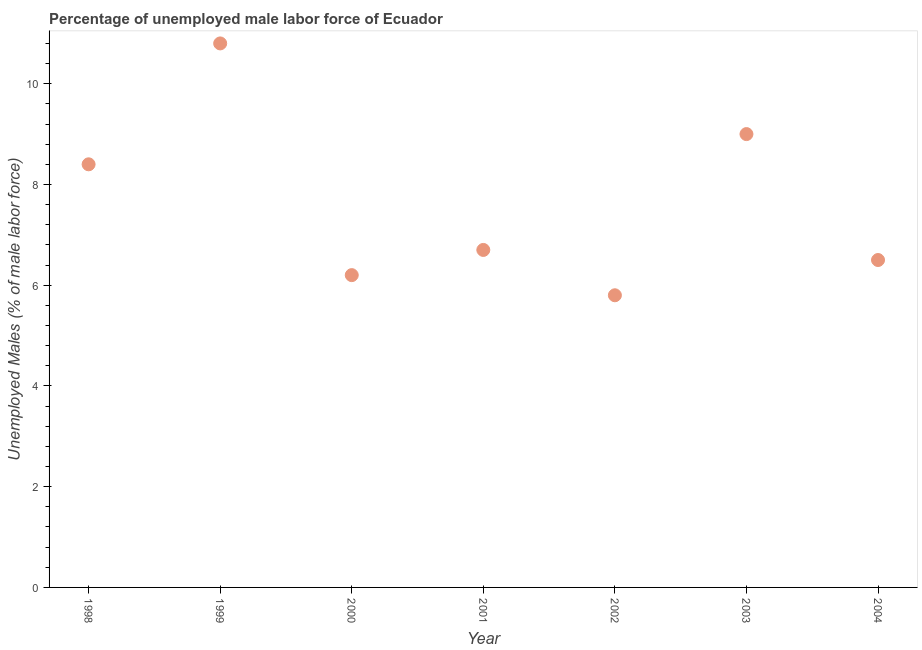What is the total unemployed male labour force in 2000?
Make the answer very short. 6.2. Across all years, what is the maximum total unemployed male labour force?
Your answer should be compact. 10.8. Across all years, what is the minimum total unemployed male labour force?
Give a very brief answer. 5.8. In which year was the total unemployed male labour force minimum?
Your answer should be compact. 2002. What is the sum of the total unemployed male labour force?
Your answer should be very brief. 53.4. What is the difference between the total unemployed male labour force in 2001 and 2002?
Give a very brief answer. 0.9. What is the average total unemployed male labour force per year?
Keep it short and to the point. 7.63. What is the median total unemployed male labour force?
Offer a terse response. 6.7. In how many years, is the total unemployed male labour force greater than 6 %?
Keep it short and to the point. 6. What is the ratio of the total unemployed male labour force in 2001 to that in 2004?
Offer a very short reply. 1.03. Is the total unemployed male labour force in 1999 less than that in 2002?
Your response must be concise. No. Is the difference between the total unemployed male labour force in 1998 and 2004 greater than the difference between any two years?
Make the answer very short. No. What is the difference between the highest and the second highest total unemployed male labour force?
Offer a very short reply. 1.8. Is the sum of the total unemployed male labour force in 1999 and 2000 greater than the maximum total unemployed male labour force across all years?
Offer a very short reply. Yes. What is the difference between the highest and the lowest total unemployed male labour force?
Provide a succinct answer. 5. How many dotlines are there?
Your answer should be compact. 1. How many years are there in the graph?
Give a very brief answer. 7. What is the difference between two consecutive major ticks on the Y-axis?
Make the answer very short. 2. Are the values on the major ticks of Y-axis written in scientific E-notation?
Offer a terse response. No. Does the graph contain any zero values?
Offer a very short reply. No. What is the title of the graph?
Your response must be concise. Percentage of unemployed male labor force of Ecuador. What is the label or title of the Y-axis?
Your answer should be compact. Unemployed Males (% of male labor force). What is the Unemployed Males (% of male labor force) in 1998?
Provide a short and direct response. 8.4. What is the Unemployed Males (% of male labor force) in 1999?
Make the answer very short. 10.8. What is the Unemployed Males (% of male labor force) in 2000?
Keep it short and to the point. 6.2. What is the Unemployed Males (% of male labor force) in 2001?
Give a very brief answer. 6.7. What is the Unemployed Males (% of male labor force) in 2002?
Provide a short and direct response. 5.8. What is the Unemployed Males (% of male labor force) in 2003?
Offer a terse response. 9. What is the Unemployed Males (% of male labor force) in 2004?
Your answer should be very brief. 6.5. What is the difference between the Unemployed Males (% of male labor force) in 1998 and 1999?
Make the answer very short. -2.4. What is the difference between the Unemployed Males (% of male labor force) in 1998 and 2000?
Make the answer very short. 2.2. What is the difference between the Unemployed Males (% of male labor force) in 1998 and 2003?
Keep it short and to the point. -0.6. What is the difference between the Unemployed Males (% of male labor force) in 1998 and 2004?
Offer a very short reply. 1.9. What is the difference between the Unemployed Males (% of male labor force) in 1999 and 2001?
Give a very brief answer. 4.1. What is the difference between the Unemployed Males (% of male labor force) in 1999 and 2003?
Your response must be concise. 1.8. What is the difference between the Unemployed Males (% of male labor force) in 1999 and 2004?
Make the answer very short. 4.3. What is the difference between the Unemployed Males (% of male labor force) in 2000 and 2001?
Your answer should be very brief. -0.5. What is the difference between the Unemployed Males (% of male labor force) in 2000 and 2003?
Ensure brevity in your answer.  -2.8. What is the difference between the Unemployed Males (% of male labor force) in 2001 and 2003?
Offer a terse response. -2.3. What is the difference between the Unemployed Males (% of male labor force) in 2002 and 2003?
Give a very brief answer. -3.2. What is the difference between the Unemployed Males (% of male labor force) in 2002 and 2004?
Provide a succinct answer. -0.7. What is the difference between the Unemployed Males (% of male labor force) in 2003 and 2004?
Provide a short and direct response. 2.5. What is the ratio of the Unemployed Males (% of male labor force) in 1998 to that in 1999?
Provide a short and direct response. 0.78. What is the ratio of the Unemployed Males (% of male labor force) in 1998 to that in 2000?
Provide a succinct answer. 1.35. What is the ratio of the Unemployed Males (% of male labor force) in 1998 to that in 2001?
Ensure brevity in your answer.  1.25. What is the ratio of the Unemployed Males (% of male labor force) in 1998 to that in 2002?
Your response must be concise. 1.45. What is the ratio of the Unemployed Males (% of male labor force) in 1998 to that in 2003?
Ensure brevity in your answer.  0.93. What is the ratio of the Unemployed Males (% of male labor force) in 1998 to that in 2004?
Offer a very short reply. 1.29. What is the ratio of the Unemployed Males (% of male labor force) in 1999 to that in 2000?
Ensure brevity in your answer.  1.74. What is the ratio of the Unemployed Males (% of male labor force) in 1999 to that in 2001?
Your answer should be compact. 1.61. What is the ratio of the Unemployed Males (% of male labor force) in 1999 to that in 2002?
Make the answer very short. 1.86. What is the ratio of the Unemployed Males (% of male labor force) in 1999 to that in 2004?
Your answer should be compact. 1.66. What is the ratio of the Unemployed Males (% of male labor force) in 2000 to that in 2001?
Offer a terse response. 0.93. What is the ratio of the Unemployed Males (% of male labor force) in 2000 to that in 2002?
Your response must be concise. 1.07. What is the ratio of the Unemployed Males (% of male labor force) in 2000 to that in 2003?
Your answer should be very brief. 0.69. What is the ratio of the Unemployed Males (% of male labor force) in 2000 to that in 2004?
Your answer should be very brief. 0.95. What is the ratio of the Unemployed Males (% of male labor force) in 2001 to that in 2002?
Keep it short and to the point. 1.16. What is the ratio of the Unemployed Males (% of male labor force) in 2001 to that in 2003?
Offer a very short reply. 0.74. What is the ratio of the Unemployed Males (% of male labor force) in 2001 to that in 2004?
Ensure brevity in your answer.  1.03. What is the ratio of the Unemployed Males (% of male labor force) in 2002 to that in 2003?
Ensure brevity in your answer.  0.64. What is the ratio of the Unemployed Males (% of male labor force) in 2002 to that in 2004?
Your answer should be compact. 0.89. What is the ratio of the Unemployed Males (% of male labor force) in 2003 to that in 2004?
Provide a short and direct response. 1.39. 